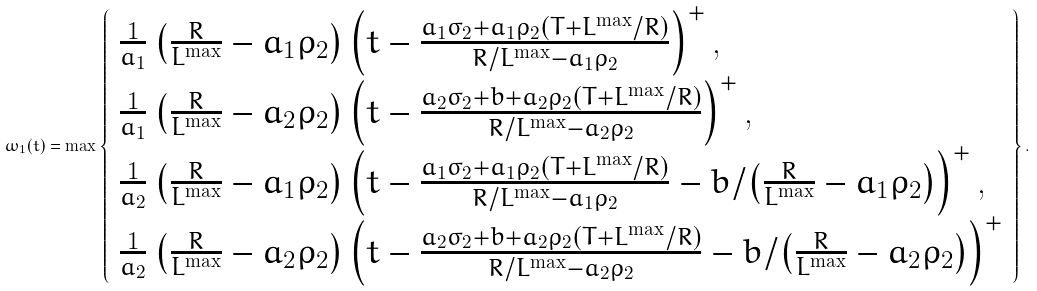<formula> <loc_0><loc_0><loc_500><loc_500>\omega _ { 1 } ( t ) = \max \left \{ \begin{array} { l } \frac { 1 } { a _ { 1 } } \left ( \frac { R } { L ^ { \max } } - a _ { 1 } \rho _ { 2 } \right ) \left ( t - \frac { a _ { 1 } \sigma _ { 2 } + a _ { 1 } \rho _ { 2 } ( T + L ^ { \max } / R ) } { R / L ^ { \max } - a _ { 1 } \rho _ { 2 } } \right ) ^ { + } , \\ \frac { 1 } { a _ { 1 } } \left ( \frac { R } { L ^ { \max } } - a _ { 2 } \rho _ { 2 } \right ) \left ( t - \frac { a _ { 2 } \sigma _ { 2 } + b + a _ { 2 } \rho _ { 2 } ( T + L ^ { \max } / R ) } { R / L ^ { \max } - a _ { 2 } \rho _ { 2 } } \right ) ^ { + } , \\ \frac { 1 } { a _ { 2 } } \left ( \frac { R } { L ^ { \max } } - a _ { 1 } \rho _ { 2 } \right ) \left ( t - \frac { a _ { 1 } \sigma _ { 2 } + a _ { 1 } \rho _ { 2 } ( T + L ^ { \max } / R ) } { R / L ^ { \max } - a _ { 1 } \rho _ { 2 } } - b / \left ( \frac { R } { L ^ { \max } } - a _ { 1 } \rho _ { 2 } \right ) \right ) ^ { + } , \\ \frac { 1 } { a _ { 2 } } \left ( \frac { R } { L ^ { \max } } - a _ { 2 } \rho _ { 2 } \right ) \left ( t - \frac { a _ { 2 } \sigma _ { 2 } + b + a _ { 2 } \rho _ { 2 } ( T + L ^ { \max } / R ) } { R / L ^ { \max } - a _ { 2 } \rho _ { 2 } } - b / \left ( \frac { R } { L ^ { \max } } - a _ { 2 } \rho _ { 2 } \right ) \right ) ^ { + } \end{array} \right \} .</formula> 